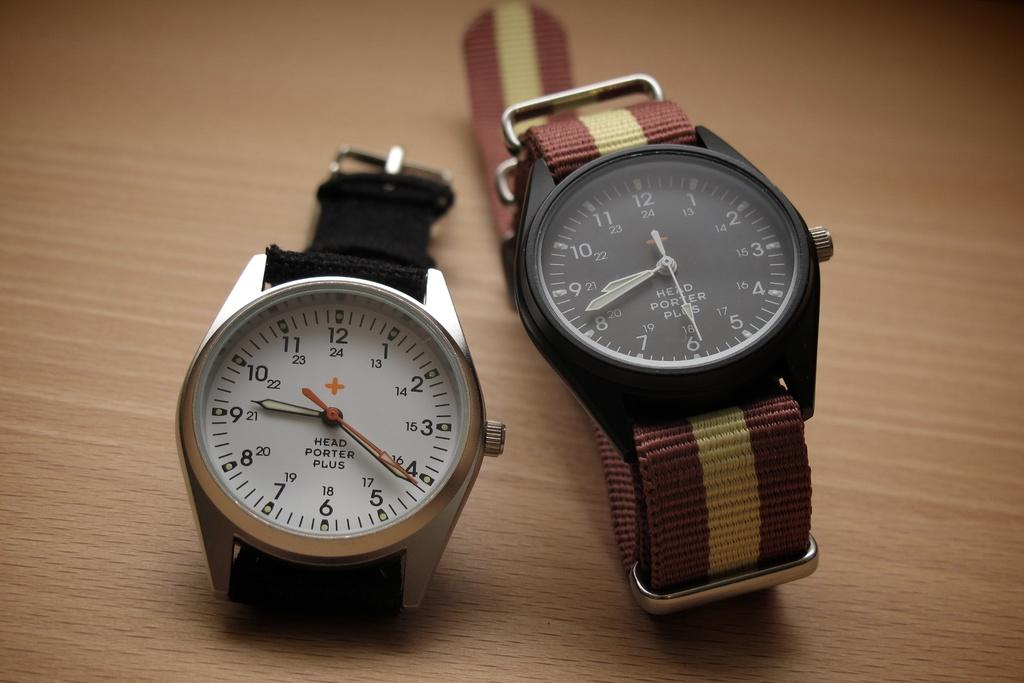<image>
Create a compact narrative representing the image presented. Two watches sit side by side, but the one on the left is about forty minutes faster than the one on the right. 